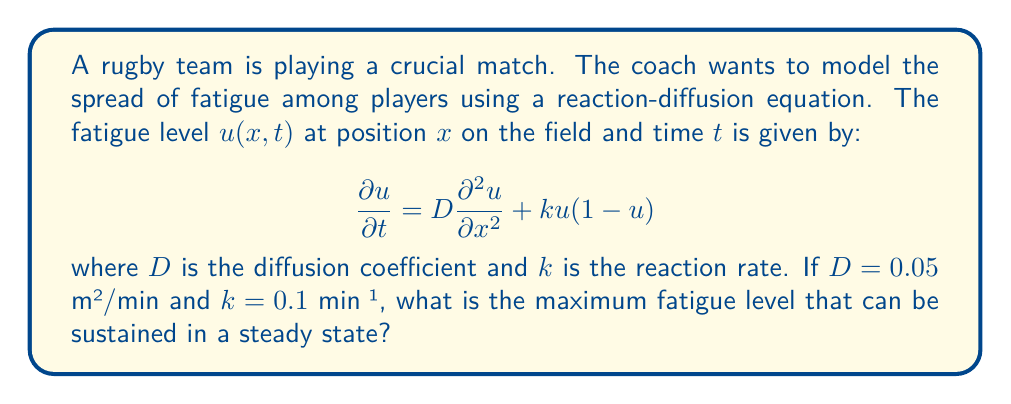Could you help me with this problem? To solve this problem, we need to understand the concept of steady state in reaction-diffusion equations. In a steady state, the fatigue level doesn't change with time, so $\frac{\partial u}{\partial t} = 0$.

Let's approach this step-by-step:

1) In steady state, the equation becomes:

   $$0 = D\frac{\partial^2 u}{\partial x^2} + ku(1-u)$$

2) The maximum sustained fatigue level will occur when there's no spatial variation, i.e., $\frac{\partial^2 u}{\partial x^2} = 0$. This reduces our equation to:

   $$0 = ku(1-u)$$

3) This equation has two solutions:
   
   $u = 0$ or $u = 1$

4) The non-zero solution, $u = 1$, represents the maximum fatigue level that can be sustained in a steady state.

5) We can verify this by substituting $u = 1$ into the original equation:

   $$\frac{\partial u}{\partial t} = D\frac{\partial^2 u}{\partial x^2} + k(1)(1-1) = 0$$

This confirms that $u = 1$ is indeed a steady state solution, regardless of the values of $D$ and $k$.
Answer: The maximum fatigue level that can be sustained in a steady state is $u = 1$. 